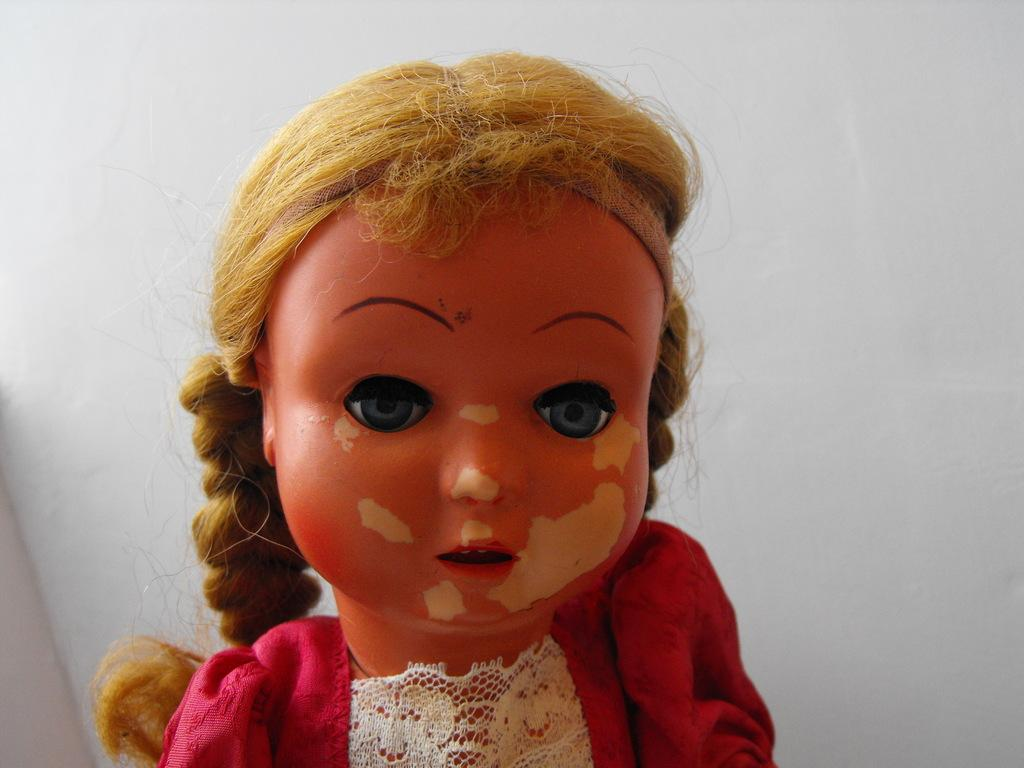What is the main subject in the image? There is a doll in the image. How many mice can be seen running around the doll in the image? There are no mice present in the image; it only features a doll. What type of medical treatment is the doll receiving in the image? The image does not depict the doll receiving any medical treatment, nor is there a hospital setting present. 